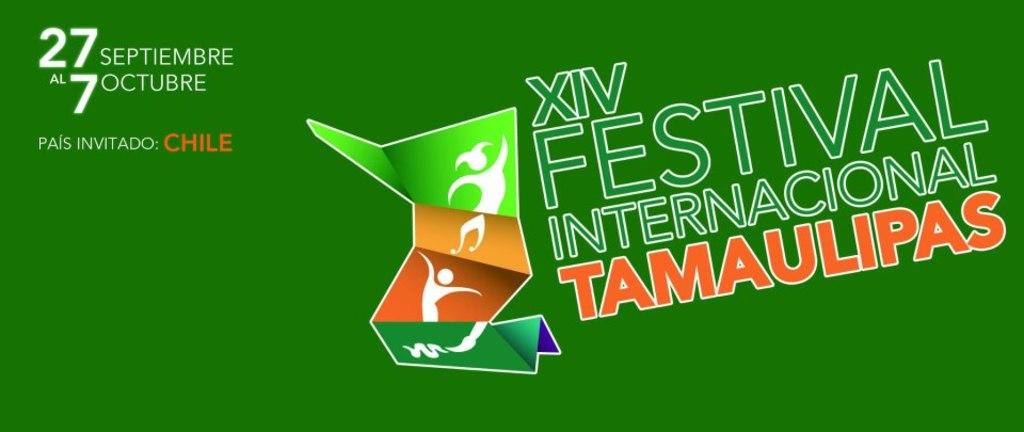When does the festival start?
Your answer should be very brief. 27 septiembre. What is the name of the festival?
Keep it short and to the point. Xiv festival internacional tamaulipas. 